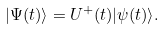<formula> <loc_0><loc_0><loc_500><loc_500>| \Psi ( t ) \rangle = U ^ { + } ( t ) | \psi ( t ) \rangle .</formula> 